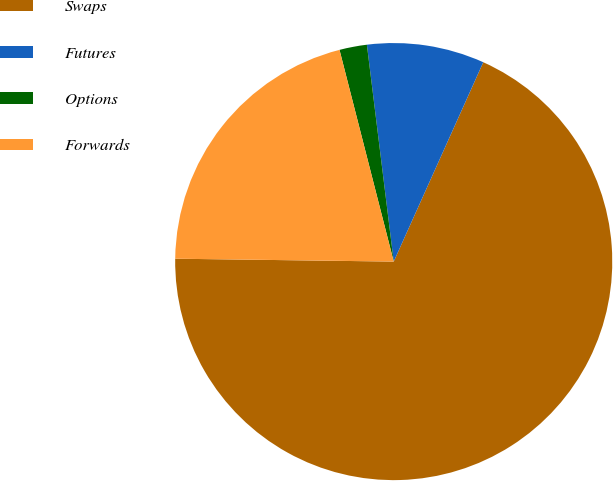Convert chart. <chart><loc_0><loc_0><loc_500><loc_500><pie_chart><fcel>Swaps<fcel>Futures<fcel>Options<fcel>Forwards<nl><fcel>68.49%<fcel>8.68%<fcel>2.03%<fcel>20.8%<nl></chart> 